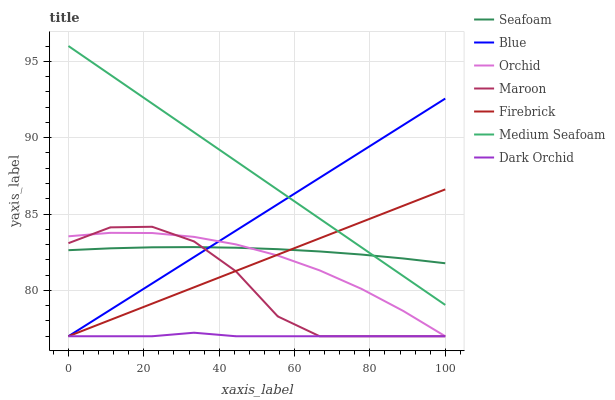Does Dark Orchid have the minimum area under the curve?
Answer yes or no. Yes. Does Medium Seafoam have the maximum area under the curve?
Answer yes or no. Yes. Does Firebrick have the minimum area under the curve?
Answer yes or no. No. Does Firebrick have the maximum area under the curve?
Answer yes or no. No. Is Firebrick the smoothest?
Answer yes or no. Yes. Is Maroon the roughest?
Answer yes or no. Yes. Is Seafoam the smoothest?
Answer yes or no. No. Is Seafoam the roughest?
Answer yes or no. No. Does Blue have the lowest value?
Answer yes or no. Yes. Does Seafoam have the lowest value?
Answer yes or no. No. Does Medium Seafoam have the highest value?
Answer yes or no. Yes. Does Firebrick have the highest value?
Answer yes or no. No. Is Maroon less than Medium Seafoam?
Answer yes or no. Yes. Is Medium Seafoam greater than Maroon?
Answer yes or no. Yes. Does Blue intersect Firebrick?
Answer yes or no. Yes. Is Blue less than Firebrick?
Answer yes or no. No. Is Blue greater than Firebrick?
Answer yes or no. No. Does Maroon intersect Medium Seafoam?
Answer yes or no. No. 